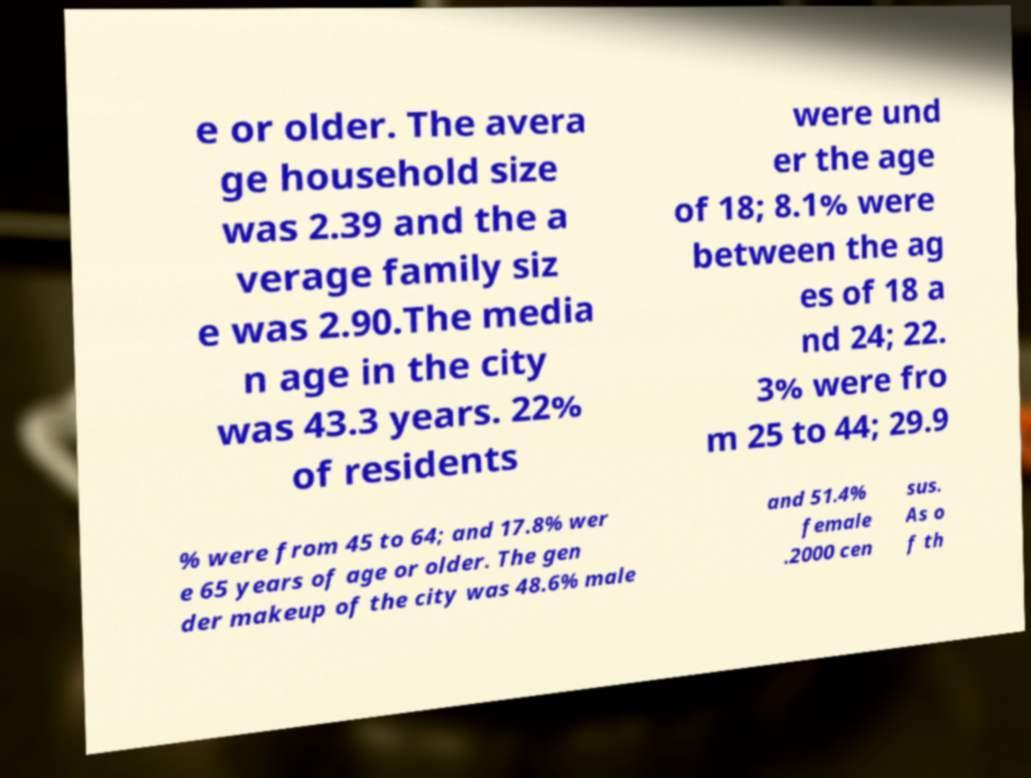I need the written content from this picture converted into text. Can you do that? e or older. The avera ge household size was 2.39 and the a verage family siz e was 2.90.The media n age in the city was 43.3 years. 22% of residents were und er the age of 18; 8.1% were between the ag es of 18 a nd 24; 22. 3% were fro m 25 to 44; 29.9 % were from 45 to 64; and 17.8% wer e 65 years of age or older. The gen der makeup of the city was 48.6% male and 51.4% female .2000 cen sus. As o f th 